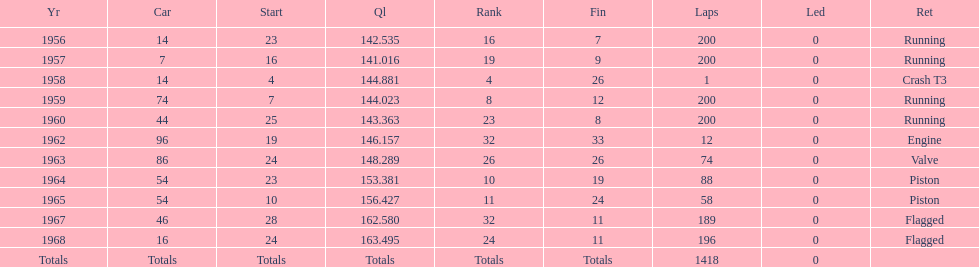Which year is the last qual on the chart 1968. 